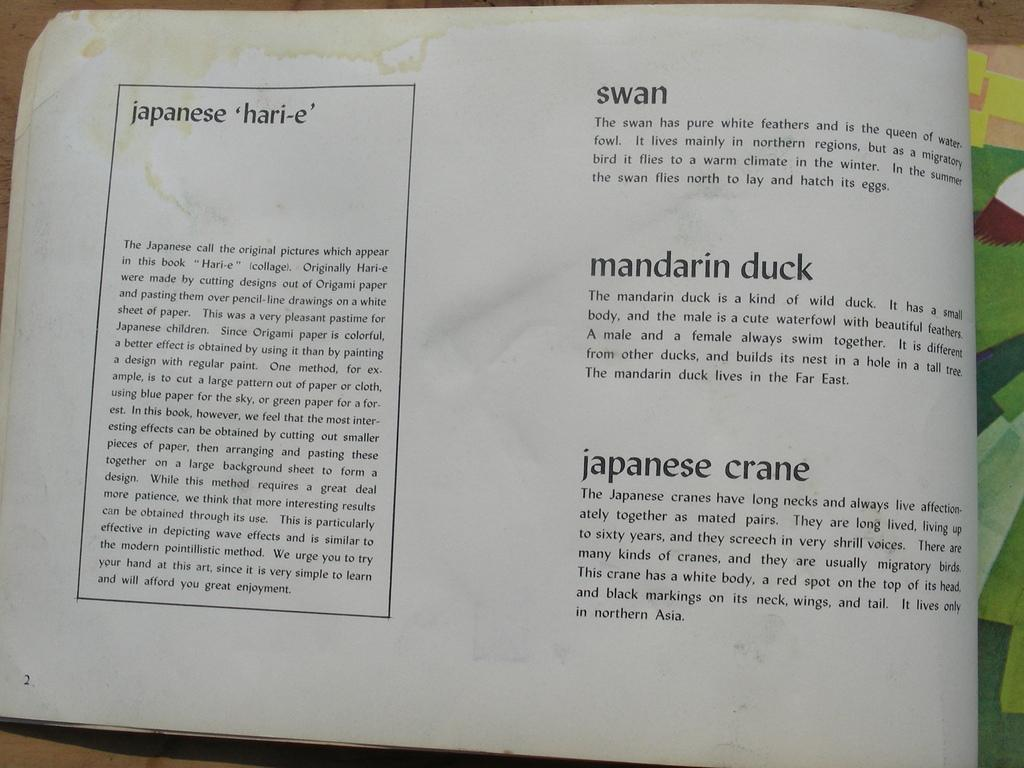<image>
Give a short and clear explanation of the subsequent image. A book is opened to a page with Swan as the first heading on the right. 